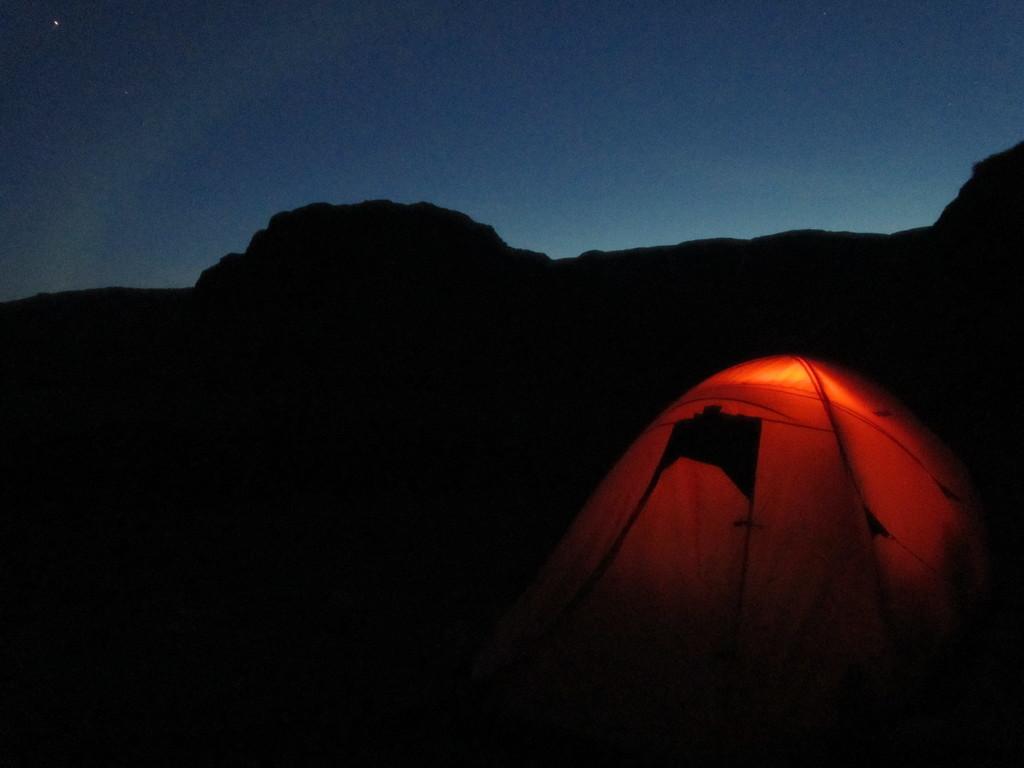Describe this image in one or two sentences. In this image, we can see a camping tent. There is a sky at the top of the image. 